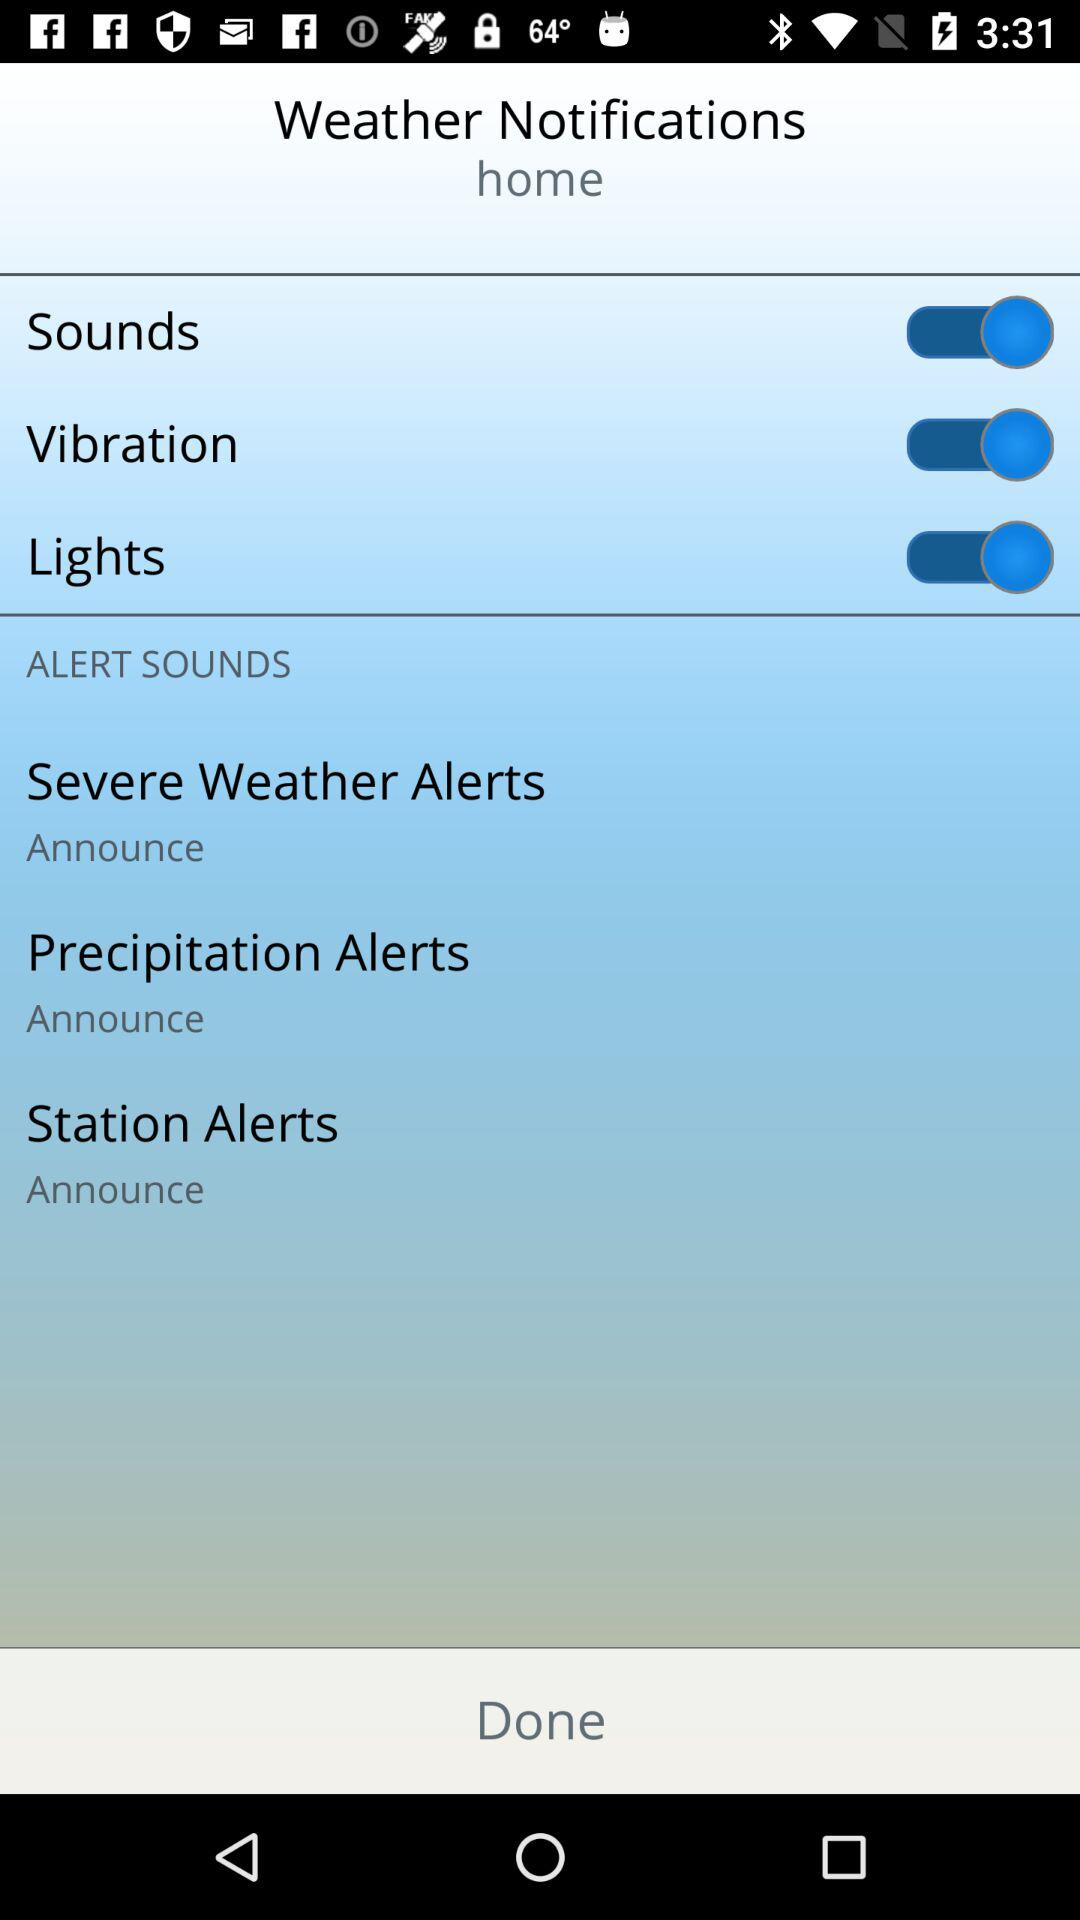How many alerts have an announce option?
Answer the question using a single word or phrase. 3 